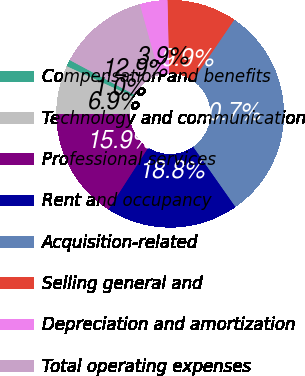Convert chart. <chart><loc_0><loc_0><loc_500><loc_500><pie_chart><fcel>Compensation and benefits<fcel>Technology and communication<fcel>Professional services<fcel>Rent and occupancy<fcel>Acquisition-related<fcel>Selling general and<fcel>Depreciation and amortization<fcel>Total operating expenses<nl><fcel>0.96%<fcel>6.92%<fcel>15.85%<fcel>18.83%<fcel>30.74%<fcel>9.89%<fcel>3.94%<fcel>12.87%<nl></chart> 